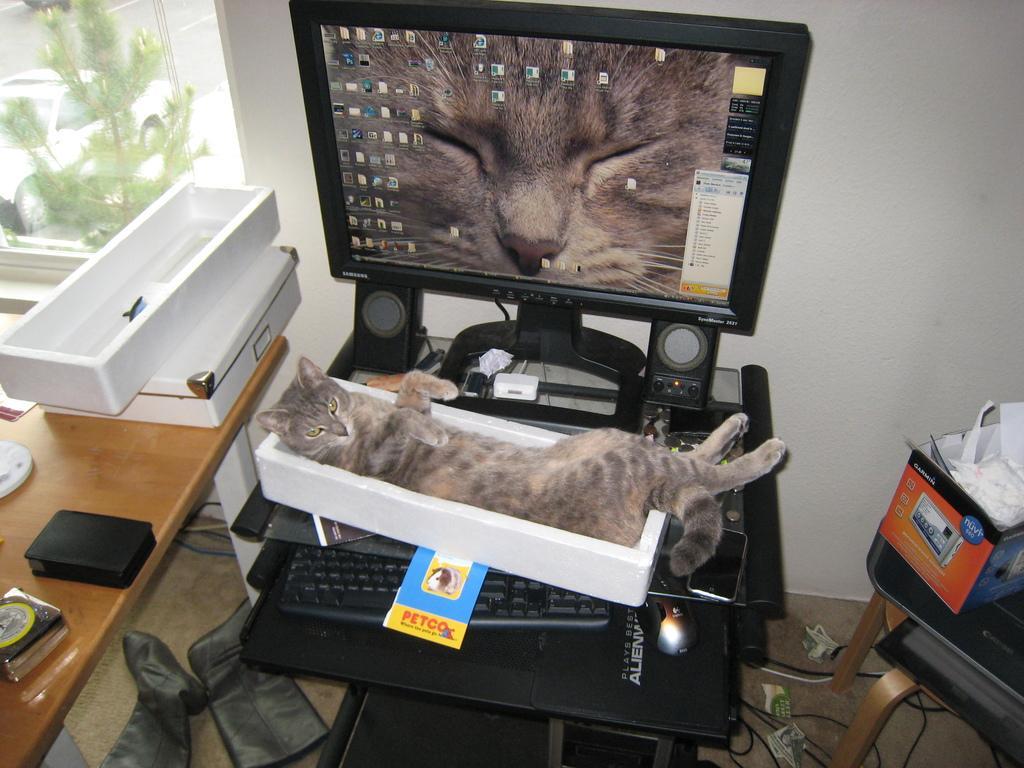Could you give a brief overview of what you see in this image? This picture is clicked inside the room. In the center of the monitor, keyboard, and cat is laying on the table. At the left side there is a box on table. In the background out of the window there is a plant. At the right side on the chair there is one box. 